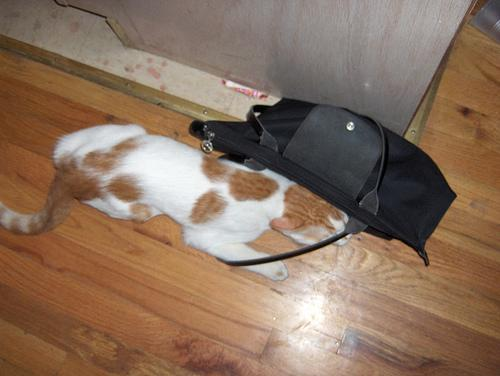What is the primary focus of the image? The primary focus is a cat sleeping under a purse or handbag. How many distinct objects are identifiable in this image? There are 9 distinct objects in the image. Provide a brief overview of the scene captured in the image. A cat is taking a nap under a purse on a wooden floor, surrounded by various objects like a candy, a plastic container, and a red crayon. What is the function of the zipper pull mentioned in the image description? The zipper pull is a part of the purse and serves as a handle to open and close the zipper. Describe the state of the cat in the image. The cat is relaxed, taking a nap, and having a rest under the purse. Name three objects placed on the floor in this image. A plastic container, a red crayon, and a roll of smarties are on the floor. What is the type of flooring visible in the image? The flooring is made of wood and has some light reflections and spots on it. What is the position of the cat relative to the purse? The cat is laying under the purse with its body partially in the handle of the purse. What emotions can be associated with this image? The image evokes feelings of relaxation, comfort, and coziness. Describe the color and pattern of the cat in the image. The cat has brown and white fur with brown spots on its back and a striped tail. 